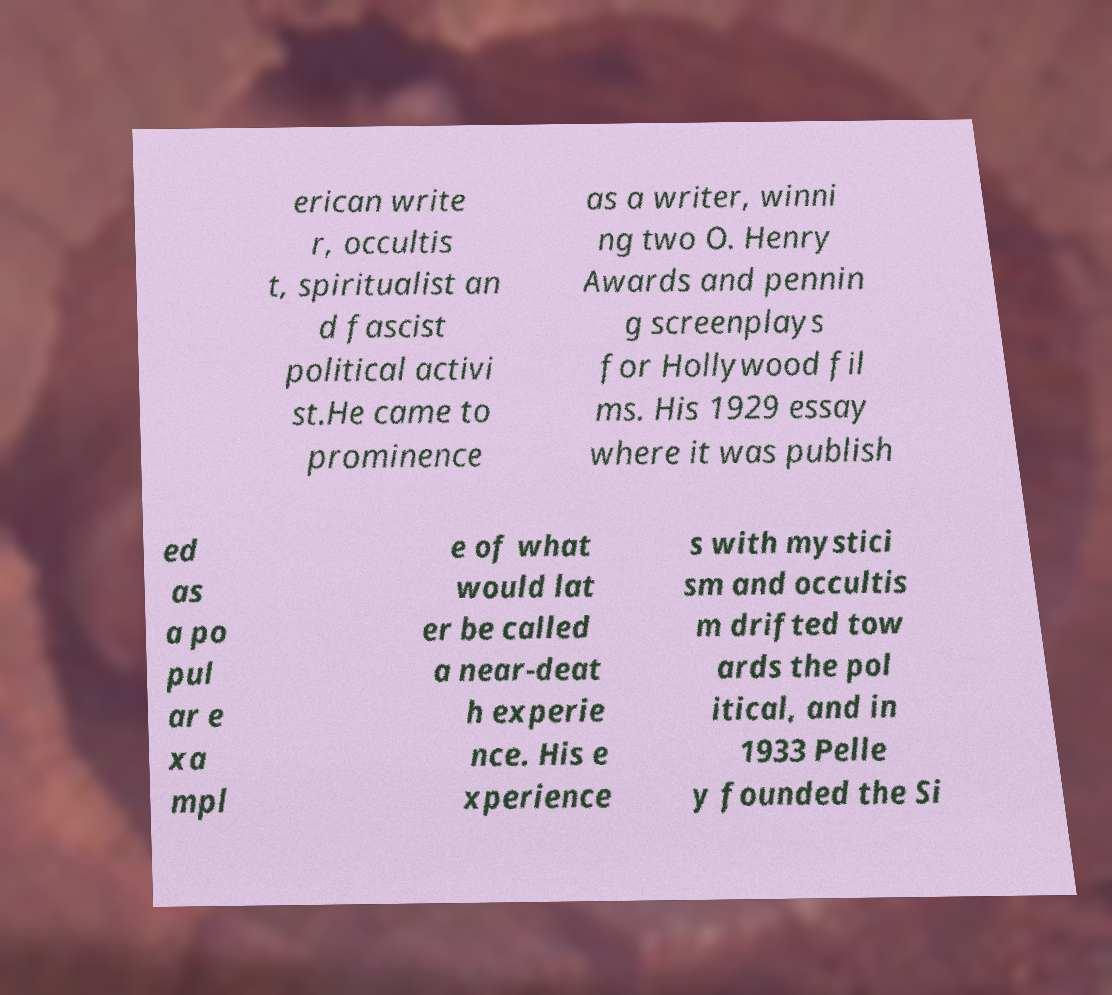For documentation purposes, I need the text within this image transcribed. Could you provide that? erican write r, occultis t, spiritualist an d fascist political activi st.He came to prominence as a writer, winni ng two O. Henry Awards and pennin g screenplays for Hollywood fil ms. His 1929 essay where it was publish ed as a po pul ar e xa mpl e of what would lat er be called a near-deat h experie nce. His e xperience s with mystici sm and occultis m drifted tow ards the pol itical, and in 1933 Pelle y founded the Si 